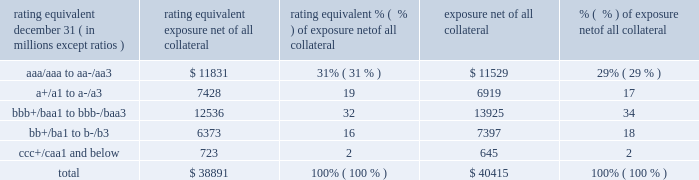Management 2019s discussion and analysis 118 jpmorgan chase & co./2018 form 10-k equivalent to the risk of loan exposures .
Dre is a less extreme measure of potential credit loss than peak and is used as an input for aggregating derivative credit risk exposures with loans and other credit risk .
Finally , avg is a measure of the expected fair value of the firm 2019s derivative receivables at future time periods , including the benefit of collateral .
Avg over the total life of the derivative contract is used as the primary metric for pricing purposes and is used to calculate credit risk capital and the cva , as further described below .
The fair value of the firm 2019s derivative receivables incorporates cva to reflect the credit quality of counterparties .
Cva is based on the firm 2019s avg to a counterparty and the counterparty 2019s credit spread in the credit derivatives market .
The firm believes that active risk management is essential to controlling the dynamic credit risk in the derivatives portfolio .
In addition , the firm 2019s risk management process takes into consideration the potential impact of wrong-way risk , which is broadly defined as the potential for increased correlation between the firm 2019s exposure to a counterparty ( avg ) and the counterparty 2019s credit quality .
Many factors may influence the nature and magnitude of these correlations over time .
To the extent that these correlations are identified , the firm may adjust the cva associated with that counterparty 2019s avg .
The firm risk manages exposure to changes in cva by entering into credit derivative contracts , as well as interest rate , foreign exchange , equity and commodity derivative contracts .
The accompanying graph shows exposure profiles to the firm 2019s current derivatives portfolio over the next 10 years as calculated by the peak , dre and avg metrics .
The three measures generally show that exposure will decline after the first year , if no new trades are added to the portfolio .
Exposure profile of derivatives measures december 31 , 2018 ( in billions ) the table summarizes the ratings profile of the firm 2019s derivative receivables , including credit derivatives , net of all collateral , at the dates indicated .
The ratings scale is based on the firm 2019s internal ratings , which generally correspond to the ratings as assigned by s&p and moody 2019s .
Ratings profile of derivative receivables .
As previously noted , the firm uses collateral agreements to mitigate counterparty credit risk .
The percentage of the firm 2019s over-the-counter derivative transactions subject to collateral agreements 2014 excluding foreign exchange spot trades , which are not typically covered by collateral agreements due to their short maturity and centrally cleared trades that are settled daily 2014 was approximately 90% ( 90 % ) at both december 31 , 2018 , and december 31 , 2017. .
What percentage of the 2017 derivative receivable ratings were ratings equivalent to junk bonds? 
Computations: (18 + 2)
Answer: 20.0. Management 2019s discussion and analysis 118 jpmorgan chase & co./2018 form 10-k equivalent to the risk of loan exposures .
Dre is a less extreme measure of potential credit loss than peak and is used as an input for aggregating derivative credit risk exposures with loans and other credit risk .
Finally , avg is a measure of the expected fair value of the firm 2019s derivative receivables at future time periods , including the benefit of collateral .
Avg over the total life of the derivative contract is used as the primary metric for pricing purposes and is used to calculate credit risk capital and the cva , as further described below .
The fair value of the firm 2019s derivative receivables incorporates cva to reflect the credit quality of counterparties .
Cva is based on the firm 2019s avg to a counterparty and the counterparty 2019s credit spread in the credit derivatives market .
The firm believes that active risk management is essential to controlling the dynamic credit risk in the derivatives portfolio .
In addition , the firm 2019s risk management process takes into consideration the potential impact of wrong-way risk , which is broadly defined as the potential for increased correlation between the firm 2019s exposure to a counterparty ( avg ) and the counterparty 2019s credit quality .
Many factors may influence the nature and magnitude of these correlations over time .
To the extent that these correlations are identified , the firm may adjust the cva associated with that counterparty 2019s avg .
The firm risk manages exposure to changes in cva by entering into credit derivative contracts , as well as interest rate , foreign exchange , equity and commodity derivative contracts .
The accompanying graph shows exposure profiles to the firm 2019s current derivatives portfolio over the next 10 years as calculated by the peak , dre and avg metrics .
The three measures generally show that exposure will decline after the first year , if no new trades are added to the portfolio .
Exposure profile of derivatives measures december 31 , 2018 ( in billions ) the table summarizes the ratings profile of the firm 2019s derivative receivables , including credit derivatives , net of all collateral , at the dates indicated .
The ratings scale is based on the firm 2019s internal ratings , which generally correspond to the ratings as assigned by s&p and moody 2019s .
Ratings profile of derivative receivables .
As previously noted , the firm uses collateral agreements to mitigate counterparty credit risk .
The percentage of the firm 2019s over-the-counter derivative transactions subject to collateral agreements 2014 excluding foreign exchange spot trades , which are not typically covered by collateral agreements due to their short maturity and centrally cleared trades that are settled daily 2014 was approximately 90% ( 90 % ) at both december 31 , 2018 , and december 31 , 2017. .
Considering the year 2018 , what is the amount of money represented by all the class b derivatives , in millions of dollars? 
Rationale: its the sum of the all the class b derivative receivables in 2018 .
Computations: (13925 + 7397)
Answer: 21322.0. 